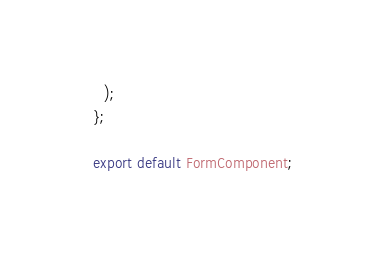<code> <loc_0><loc_0><loc_500><loc_500><_TypeScript_>    );
  };

  export default FormComponent;</code> 